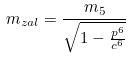Convert formula to latex. <formula><loc_0><loc_0><loc_500><loc_500>m _ { z a l } = \frac { m _ { 5 } } { \sqrt { 1 - \frac { p ^ { 6 } } { c ^ { 6 } } } }</formula> 